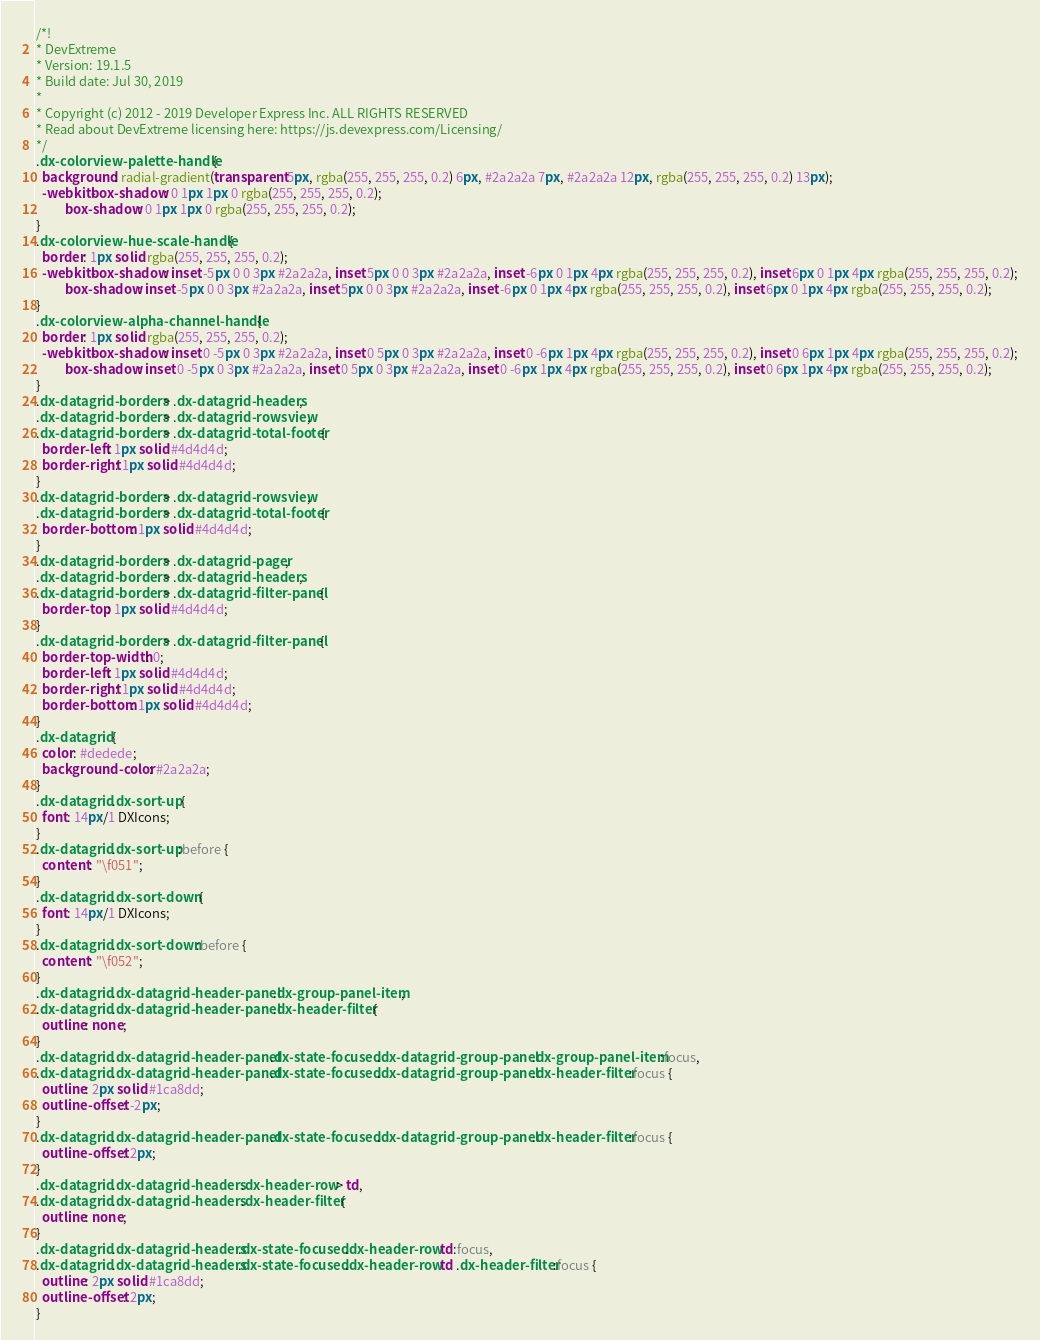<code> <loc_0><loc_0><loc_500><loc_500><_CSS_>/*!
* DevExtreme
* Version: 19.1.5
* Build date: Jul 30, 2019
*
* Copyright (c) 2012 - 2019 Developer Express Inc. ALL RIGHTS RESERVED
* Read about DevExtreme licensing here: https://js.devexpress.com/Licensing/
*/
.dx-colorview-palette-handle {
  background: radial-gradient(transparent 5px, rgba(255, 255, 255, 0.2) 6px, #2a2a2a 7px, #2a2a2a 12px, rgba(255, 255, 255, 0.2) 13px);
  -webkit-box-shadow: 0 1px 1px 0 rgba(255, 255, 255, 0.2);
          box-shadow: 0 1px 1px 0 rgba(255, 255, 255, 0.2);
}
.dx-colorview-hue-scale-handle {
  border: 1px solid rgba(255, 255, 255, 0.2);
  -webkit-box-shadow: inset -5px 0 0 3px #2a2a2a, inset 5px 0 0 3px #2a2a2a, inset -6px 0 1px 4px rgba(255, 255, 255, 0.2), inset 6px 0 1px 4px rgba(255, 255, 255, 0.2);
          box-shadow: inset -5px 0 0 3px #2a2a2a, inset 5px 0 0 3px #2a2a2a, inset -6px 0 1px 4px rgba(255, 255, 255, 0.2), inset 6px 0 1px 4px rgba(255, 255, 255, 0.2);
}
.dx-colorview-alpha-channel-handle {
  border: 1px solid rgba(255, 255, 255, 0.2);
  -webkit-box-shadow: inset 0 -5px 0 3px #2a2a2a, inset 0 5px 0 3px #2a2a2a, inset 0 -6px 1px 4px rgba(255, 255, 255, 0.2), inset 0 6px 1px 4px rgba(255, 255, 255, 0.2);
          box-shadow: inset 0 -5px 0 3px #2a2a2a, inset 0 5px 0 3px #2a2a2a, inset 0 -6px 1px 4px rgba(255, 255, 255, 0.2), inset 0 6px 1px 4px rgba(255, 255, 255, 0.2);
}
.dx-datagrid-borders > .dx-datagrid-headers,
.dx-datagrid-borders > .dx-datagrid-rowsview,
.dx-datagrid-borders > .dx-datagrid-total-footer {
  border-left: 1px solid #4d4d4d;
  border-right: 1px solid #4d4d4d;
}
.dx-datagrid-borders > .dx-datagrid-rowsview,
.dx-datagrid-borders > .dx-datagrid-total-footer {
  border-bottom: 1px solid #4d4d4d;
}
.dx-datagrid-borders > .dx-datagrid-pager,
.dx-datagrid-borders > .dx-datagrid-headers,
.dx-datagrid-borders > .dx-datagrid-filter-panel {
  border-top: 1px solid #4d4d4d;
}
.dx-datagrid-borders > .dx-datagrid-filter-panel {
  border-top-width: 0;
  border-left: 1px solid #4d4d4d;
  border-right: 1px solid #4d4d4d;
  border-bottom: 1px solid #4d4d4d;
}
.dx-datagrid {
  color: #dedede;
  background-color: #2a2a2a;
}
.dx-datagrid .dx-sort-up {
  font: 14px/1 DXIcons;
}
.dx-datagrid .dx-sort-up:before {
  content: "\f051";
}
.dx-datagrid .dx-sort-down {
  font: 14px/1 DXIcons;
}
.dx-datagrid .dx-sort-down:before {
  content: "\f052";
}
.dx-datagrid .dx-datagrid-header-panel .dx-group-panel-item,
.dx-datagrid .dx-datagrid-header-panel .dx-header-filter {
  outline: none;
}
.dx-datagrid .dx-datagrid-header-panel.dx-state-focused .dx-datagrid-group-panel .dx-group-panel-item:focus,
.dx-datagrid .dx-datagrid-header-panel.dx-state-focused .dx-datagrid-group-panel .dx-header-filter:focus {
  outline: 2px solid #1ca8dd;
  outline-offset: -2px;
}
.dx-datagrid .dx-datagrid-header-panel.dx-state-focused .dx-datagrid-group-panel .dx-header-filter:focus {
  outline-offset: 2px;
}
.dx-datagrid .dx-datagrid-headers .dx-header-row > td,
.dx-datagrid .dx-datagrid-headers .dx-header-filter {
  outline: none;
}
.dx-datagrid .dx-datagrid-headers.dx-state-focused .dx-header-row td:focus,
.dx-datagrid .dx-datagrid-headers.dx-state-focused .dx-header-row td .dx-header-filter:focus {
  outline: 2px solid #1ca8dd;
  outline-offset: 2px;
}</code> 